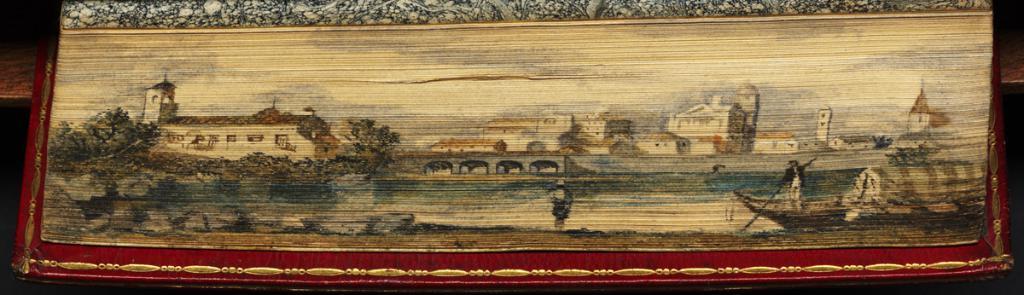Could you give a brief overview of what you see in this image? In the foreground of this picture, there is a frame with a scenery. In the scenery, there is a man on a boat on the water, bridge, trees, buildings and the sky. 